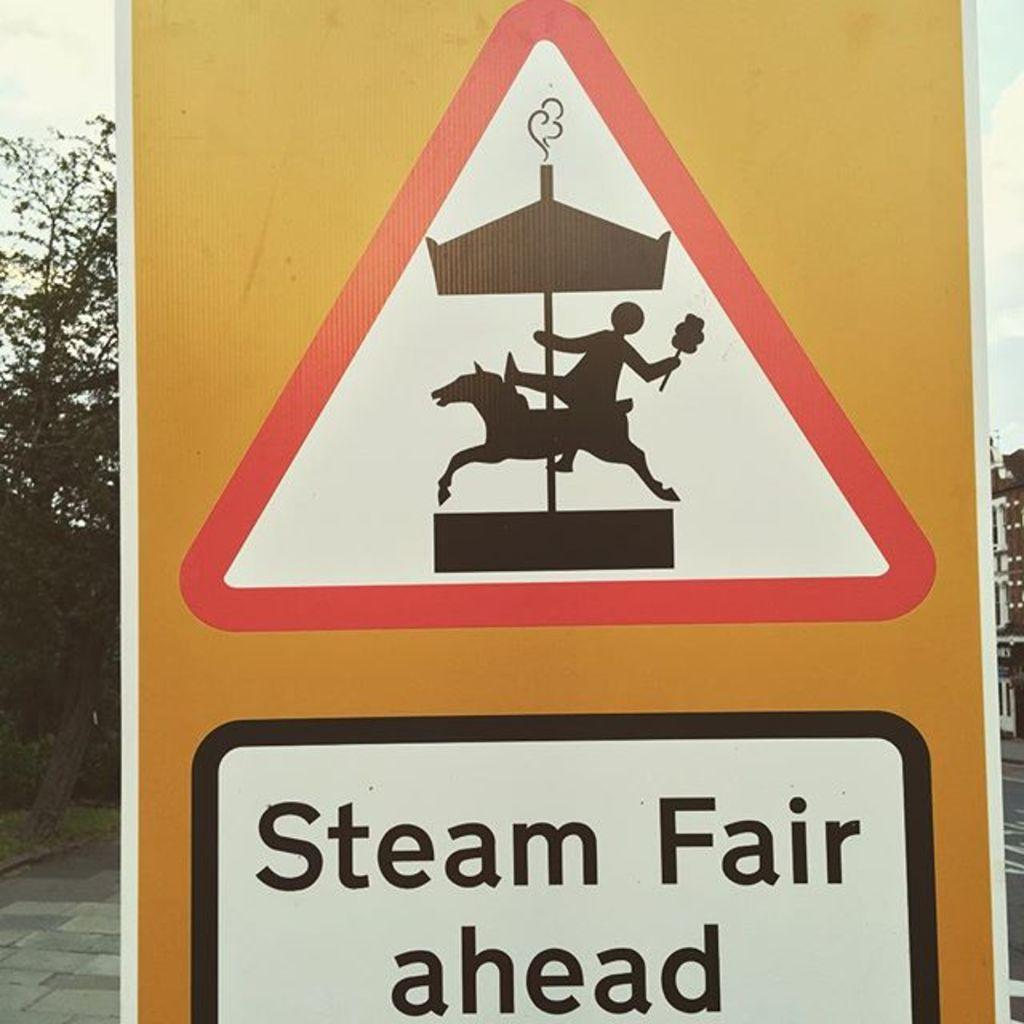Provide a one-sentence caption for the provided image. A yellow sign shows a carousel and reads "Steam Fair Ahead". 